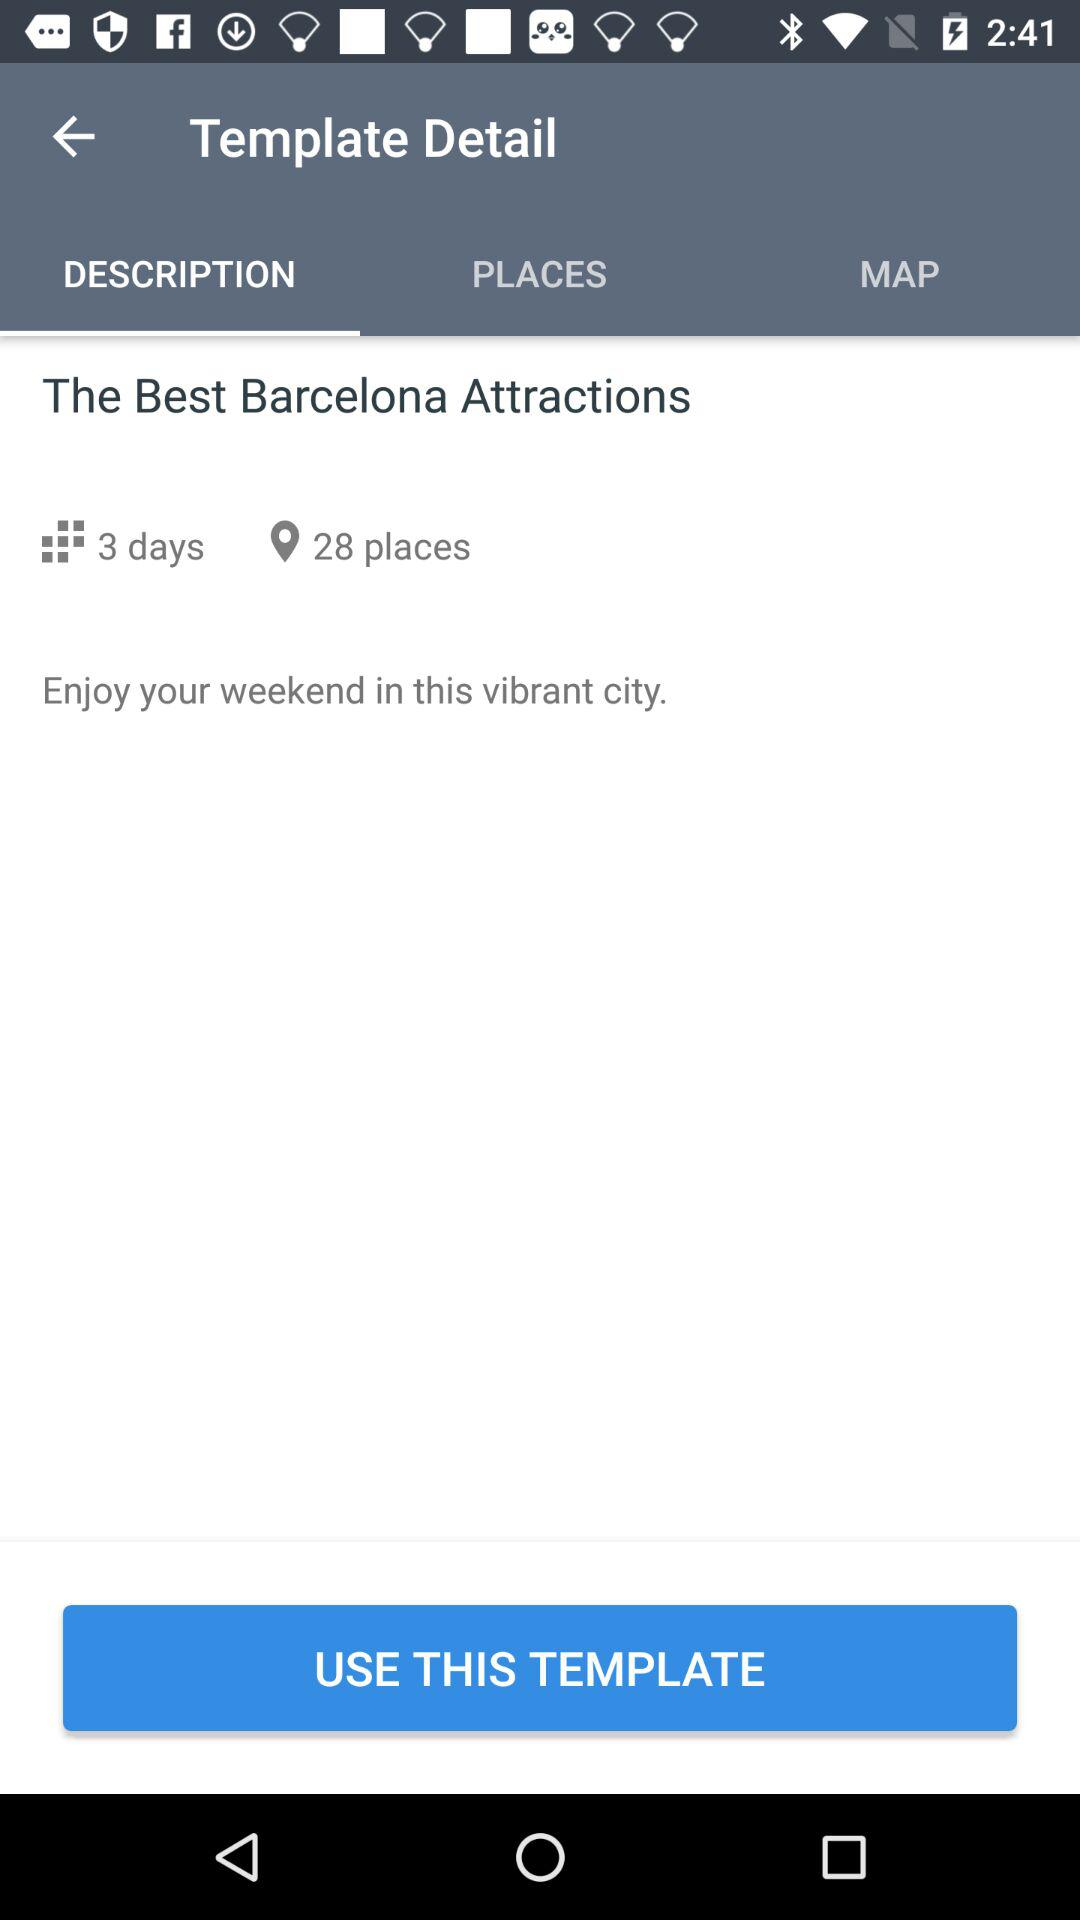How many places are in the itinerary?
Answer the question using a single word or phrase. 28 